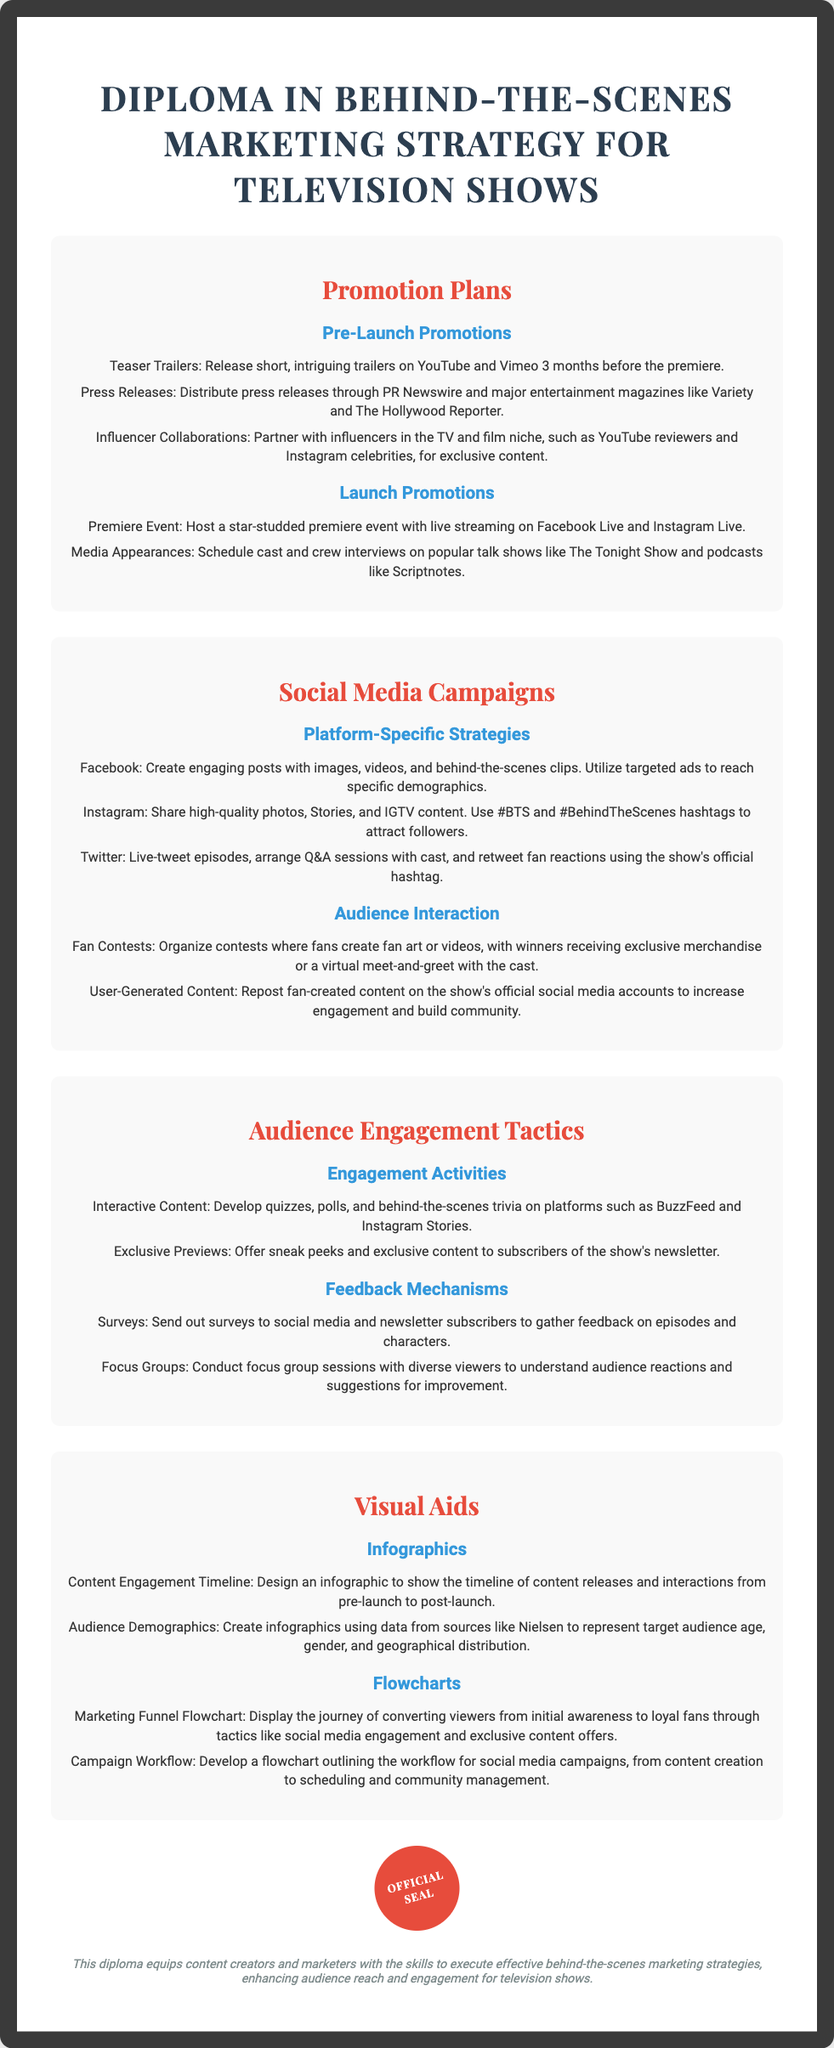what is the title of the diploma? The title of the diploma is prominently displayed at the top of the document.
Answer: Diploma in Behind-the-Scenes Marketing Strategy for Television Shows how many pre-launch promotion strategies are listed? The document outlines specific pre-launch promotions under the Promotion Plans section, giving a total count.
Answer: 3 which platform is mentioned for launching teaser trailers? The document includes the platforms where teaser trailers will be released under Pre-Launch Promotions.
Answer: YouTube and Vimeo what is one type of interactive content suggested for audience engagement? Interactive content suggestions are listed, and one specific type is mentioned.
Answer: Quizzes how are media appearances categorized in the document? The document categorizes media appearances under Launch Promotions within the Promotion Plans section.
Answer: Launch Promotions how is audience feedback gathered according to the document? The document outlines specific methods to gather audience feedback.
Answer: Surveys what is a goal of the marketing funnel flowchart mentioned? The document states the purpose of the marketing funnel flowchart in context.
Answer: Converting viewers name a social media platform used for contests. The document mentions a platform where fan contests can be held in the Audience Interaction section.
Answer: Instagram how are exclusive previews delivered to the audience? The document outlines how exclusive previews will be provided to the audience for engagement.
Answer: Newsletter subscribers 